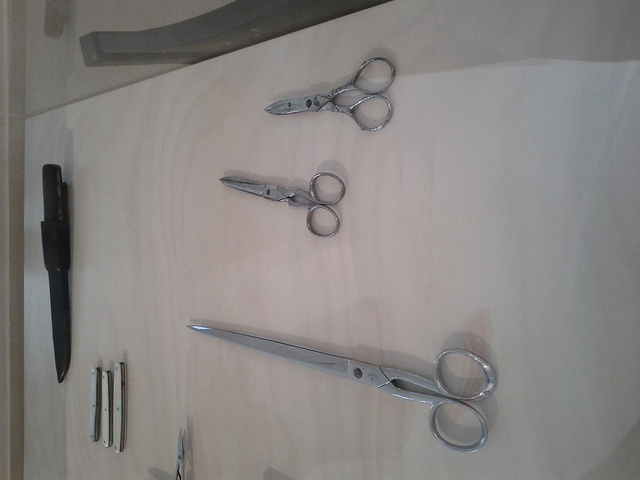Describe the objects in this image and their specific colors. I can see chair in gray and black tones, scissors in gray tones, knife in gray, black, and purple tones, scissors in gray tones, and scissors in gray and black tones in this image. 